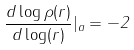<formula> <loc_0><loc_0><loc_500><loc_500>\frac { d \log \rho ( r ) } { d \log ( r ) } | _ { a } = - 2</formula> 